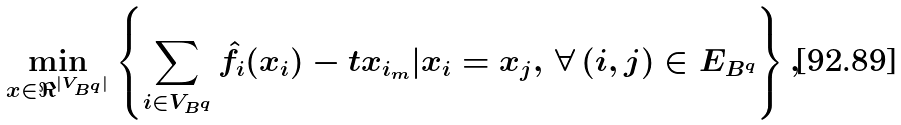Convert formula to latex. <formula><loc_0><loc_0><loc_500><loc_500>\min _ { x \in \Re ^ { | V _ { B ^ { q } } | } } \left \{ \sum _ { i \in V _ { B ^ { q } } } \hat { f } _ { i } ( x _ { i } ) - t x _ { i _ { m } } | x _ { i } = x _ { j } , \, \forall \, ( i , j ) \in E _ { B ^ { q } } \right \} ,</formula> 